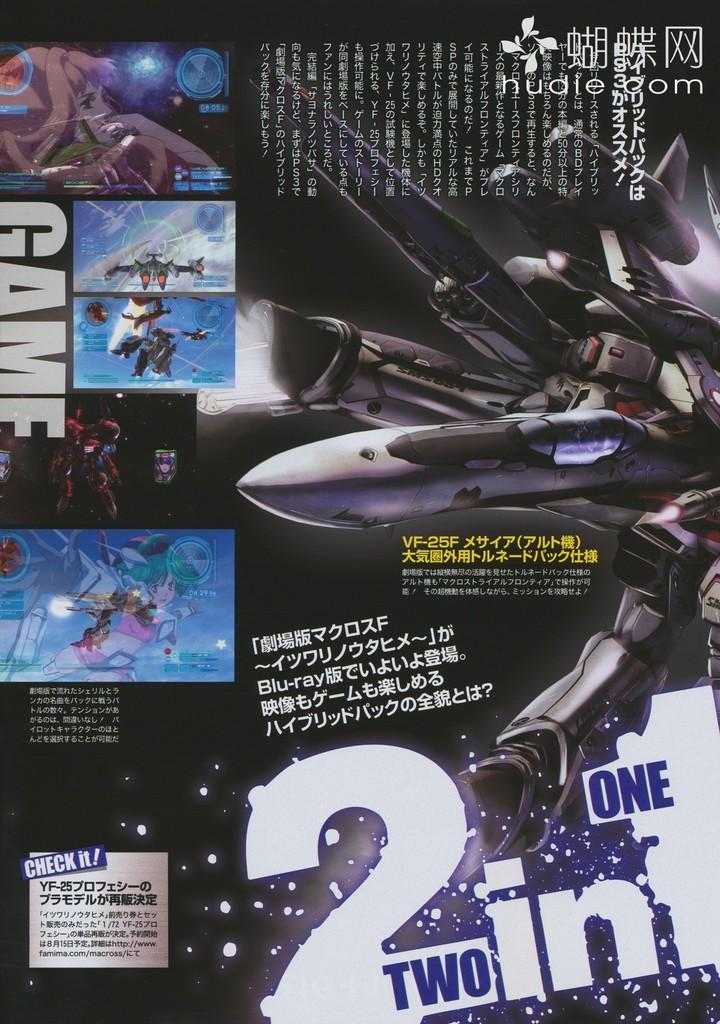<image>
Provide a brief description of the given image. An add that says two in one with multiple images 